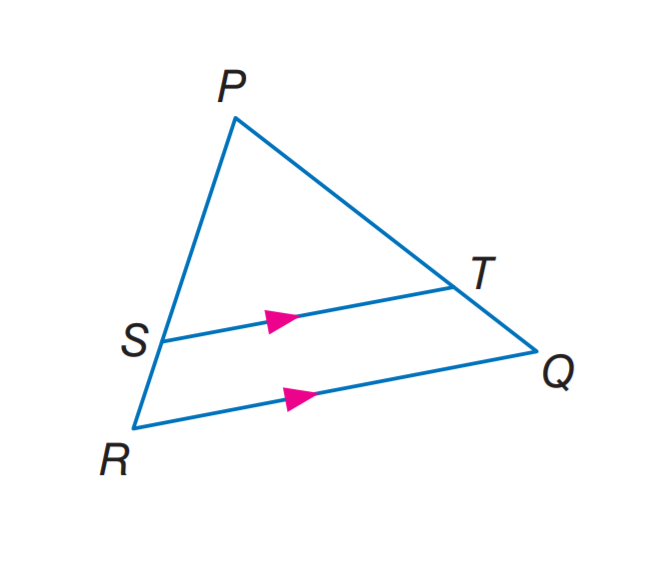Answer the mathemtical geometry problem and directly provide the correct option letter.
Question: In \triangle P Q R, S T \parallel R Q. If P T = 7.5, T Q = 3, and S R = 2.5, find P S.
Choices: A: 2.5 B: 6 C: 6.25 D: 7.5 C 